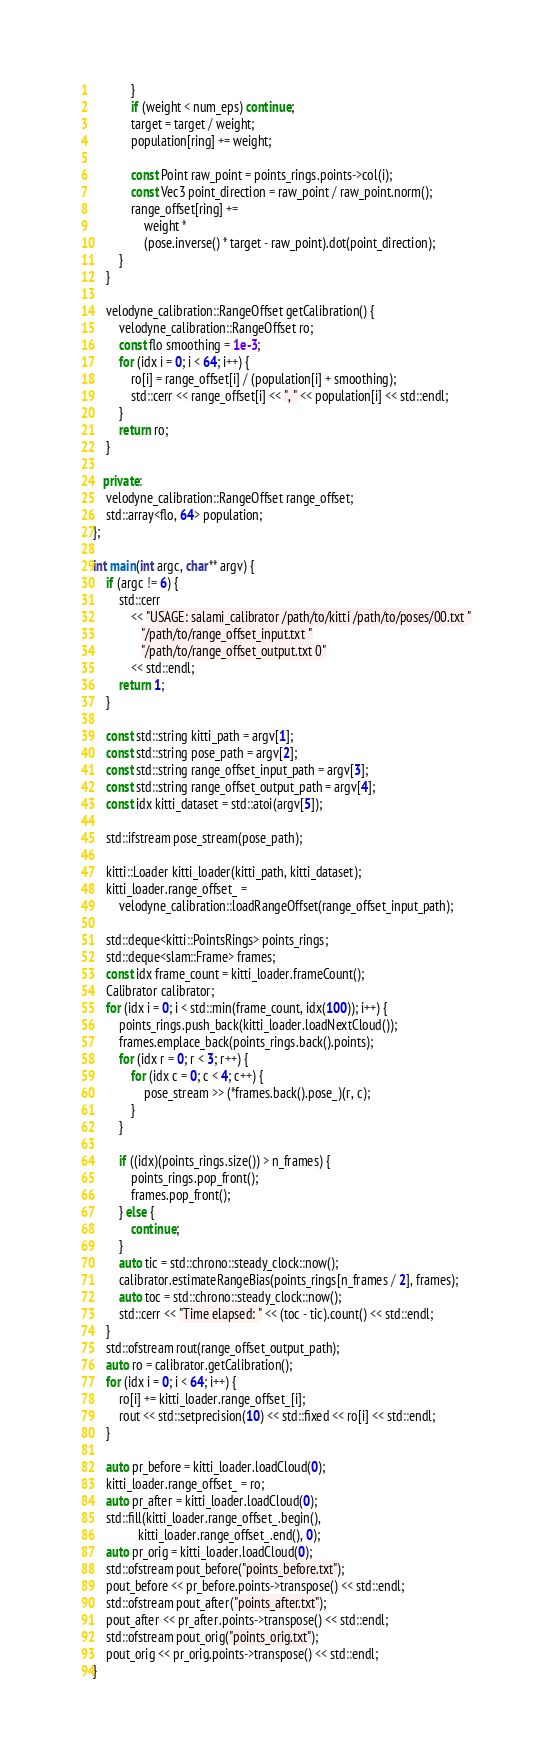Convert code to text. <code><loc_0><loc_0><loc_500><loc_500><_C++_>            }
            if (weight < num_eps) continue;
            target = target / weight;
            population[ring] += weight;

            const Point raw_point = points_rings.points->col(i);
            const Vec3 point_direction = raw_point / raw_point.norm();
            range_offset[ring] +=
                weight *
                (pose.inverse() * target - raw_point).dot(point_direction);
        }
    }

    velodyne_calibration::RangeOffset getCalibration() {
        velodyne_calibration::RangeOffset ro;
        const flo smoothing = 1e-3;
        for (idx i = 0; i < 64; i++) {
            ro[i] = range_offset[i] / (population[i] + smoothing);
            std::cerr << range_offset[i] << ", " << population[i] << std::endl;
        }
        return ro;
    }

   private:
    velodyne_calibration::RangeOffset range_offset;
    std::array<flo, 64> population;
};

int main(int argc, char** argv) {
    if (argc != 6) {
        std::cerr
            << "USAGE: salami_calibrator /path/to/kitti /path/to/poses/00.txt "
               "/path/to/range_offset_input.txt "
               "/path/to/range_offset_output.txt 0"
            << std::endl;
        return 1;
    }

    const std::string kitti_path = argv[1];
    const std::string pose_path = argv[2];
    const std::string range_offset_input_path = argv[3];
    const std::string range_offset_output_path = argv[4];
    const idx kitti_dataset = std::atoi(argv[5]);

    std::ifstream pose_stream(pose_path);

    kitti::Loader kitti_loader(kitti_path, kitti_dataset);
    kitti_loader.range_offset_ =
        velodyne_calibration::loadRangeOffset(range_offset_input_path);

    std::deque<kitti::PointsRings> points_rings;
    std::deque<slam::Frame> frames;
    const idx frame_count = kitti_loader.frameCount();
    Calibrator calibrator;
    for (idx i = 0; i < std::min(frame_count, idx(100)); i++) {
        points_rings.push_back(kitti_loader.loadNextCloud());
        frames.emplace_back(points_rings.back().points);
        for (idx r = 0; r < 3; r++) {
            for (idx c = 0; c < 4; c++) {
                pose_stream >> (*frames.back().pose_)(r, c);
            }
        }

        if ((idx)(points_rings.size()) > n_frames) {
            points_rings.pop_front();
            frames.pop_front();
        } else {
            continue;
        }
        auto tic = std::chrono::steady_clock::now();
        calibrator.estimateRangeBias(points_rings[n_frames / 2], frames);
        auto toc = std::chrono::steady_clock::now();
        std::cerr << "Time elapsed: " << (toc - tic).count() << std::endl;
    }
    std::ofstream rout(range_offset_output_path);
    auto ro = calibrator.getCalibration();
    for (idx i = 0; i < 64; i++) {
        ro[i] += kitti_loader.range_offset_[i];
        rout << std::setprecision(10) << std::fixed << ro[i] << std::endl;
    }

    auto pr_before = kitti_loader.loadCloud(0);
    kitti_loader.range_offset_ = ro;
    auto pr_after = kitti_loader.loadCloud(0);
    std::fill(kitti_loader.range_offset_.begin(),
              kitti_loader.range_offset_.end(), 0);
    auto pr_orig = kitti_loader.loadCloud(0);
    std::ofstream pout_before("points_before.txt");
    pout_before << pr_before.points->transpose() << std::endl;
    std::ofstream pout_after("points_after.txt");
    pout_after << pr_after.points->transpose() << std::endl;
    std::ofstream pout_orig("points_orig.txt");
    pout_orig << pr_orig.points->transpose() << std::endl;
}
</code> 